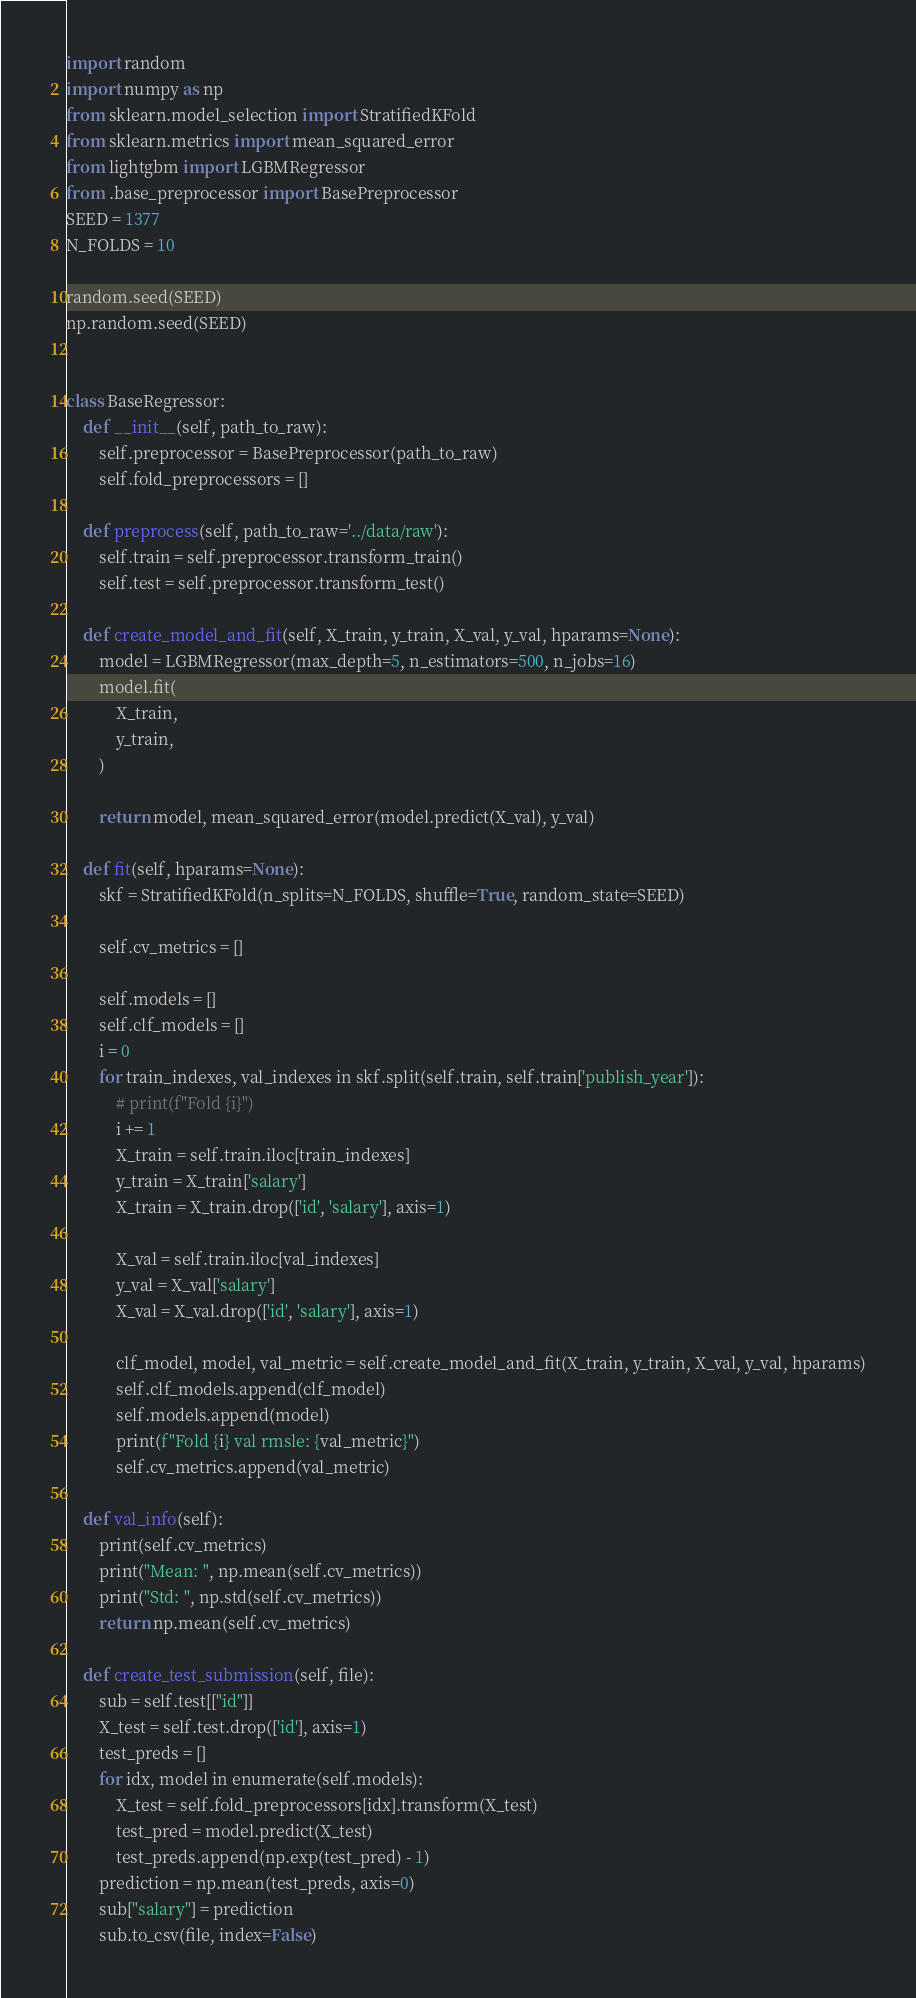<code> <loc_0><loc_0><loc_500><loc_500><_Python_>import random
import numpy as np
from sklearn.model_selection import StratifiedKFold
from sklearn.metrics import mean_squared_error
from lightgbm import LGBMRegressor
from .base_preprocessor import BasePreprocessor
SEED = 1377
N_FOLDS = 10

random.seed(SEED)
np.random.seed(SEED)


class BaseRegressor:
    def __init__(self, path_to_raw):
        self.preprocessor = BasePreprocessor(path_to_raw)
        self.fold_preprocessors = []

    def preprocess(self, path_to_raw='../data/raw'):
        self.train = self.preprocessor.transform_train()
        self.test = self.preprocessor.transform_test()

    def create_model_and_fit(self, X_train, y_train, X_val, y_val, hparams=None):
        model = LGBMRegressor(max_depth=5, n_estimators=500, n_jobs=16)
        model.fit(
            X_train,
            y_train,
        )

        return model, mean_squared_error(model.predict(X_val), y_val)

    def fit(self, hparams=None):
        skf = StratifiedKFold(n_splits=N_FOLDS, shuffle=True, random_state=SEED)

        self.cv_metrics = []

        self.models = []
        self.clf_models = []
        i = 0
        for train_indexes, val_indexes in skf.split(self.train, self.train['publish_year']):
            # print(f"Fold {i}")
            i += 1
            X_train = self.train.iloc[train_indexes]
            y_train = X_train['salary']
            X_train = X_train.drop(['id', 'salary'], axis=1)

            X_val = self.train.iloc[val_indexes]
            y_val = X_val['salary']
            X_val = X_val.drop(['id', 'salary'], axis=1)

            clf_model, model, val_metric = self.create_model_and_fit(X_train, y_train, X_val, y_val, hparams)
            self.clf_models.append(clf_model)
            self.models.append(model)
            print(f"Fold {i} val rmsle: {val_metric}")
            self.cv_metrics.append(val_metric)

    def val_info(self):
        print(self.cv_metrics)
        print("Mean: ", np.mean(self.cv_metrics))
        print("Std: ", np.std(self.cv_metrics))
        return np.mean(self.cv_metrics)

    def create_test_submission(self, file):
        sub = self.test[["id"]]
        X_test = self.test.drop(['id'], axis=1)
        test_preds = []
        for idx, model in enumerate(self.models):
            X_test = self.fold_preprocessors[idx].transform(X_test)
            test_pred = model.predict(X_test)
            test_preds.append(np.exp(test_pred) - 1)
        prediction = np.mean(test_preds, axis=0)
        sub["salary"] = prediction
        sub.to_csv(file, index=False)
</code> 